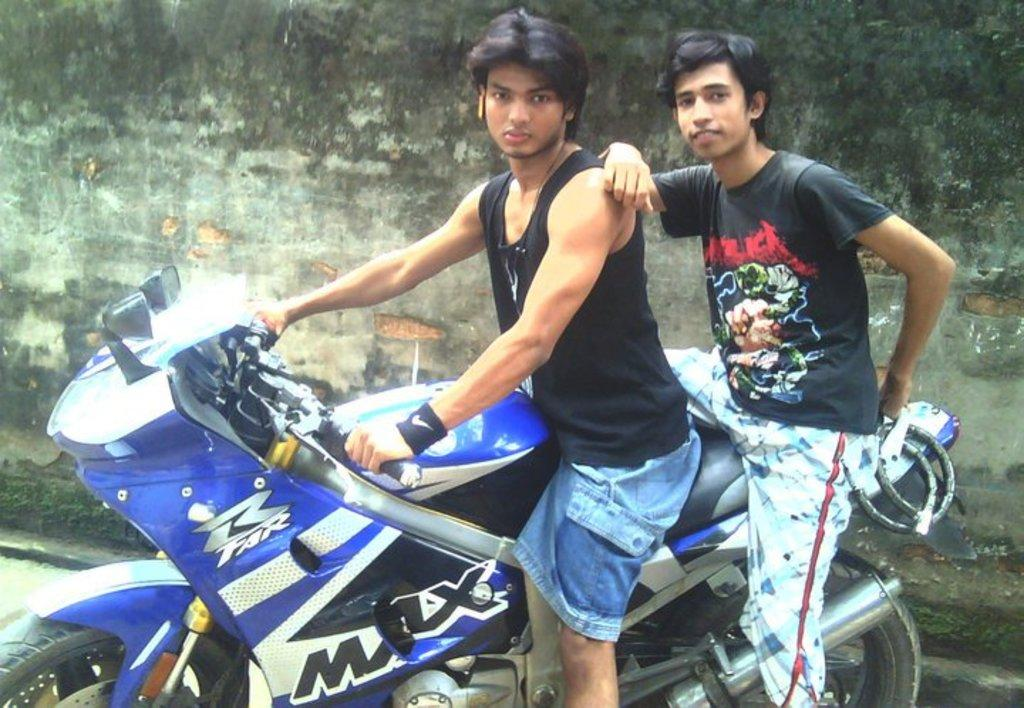How many people are in the image? There are two persons in the image. What are the two persons doing in the image? The two persons are sitting on a blue color bike. What can be seen in the background of the image? There is a wall in the background of the image. What type of glove is the person on the left wearing in the image? There is no glove visible on either person in the image. Is there a boat present in the image? No, there is no boat present in the image. 